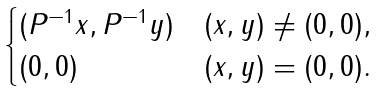Convert formula to latex. <formula><loc_0><loc_0><loc_500><loc_500>\begin{cases} ( P ^ { - 1 } x , P ^ { - 1 } y ) & ( x , y ) \ne ( 0 , 0 ) , \\ ( 0 , 0 ) & ( x , y ) = ( 0 , 0 ) . \end{cases}</formula> 